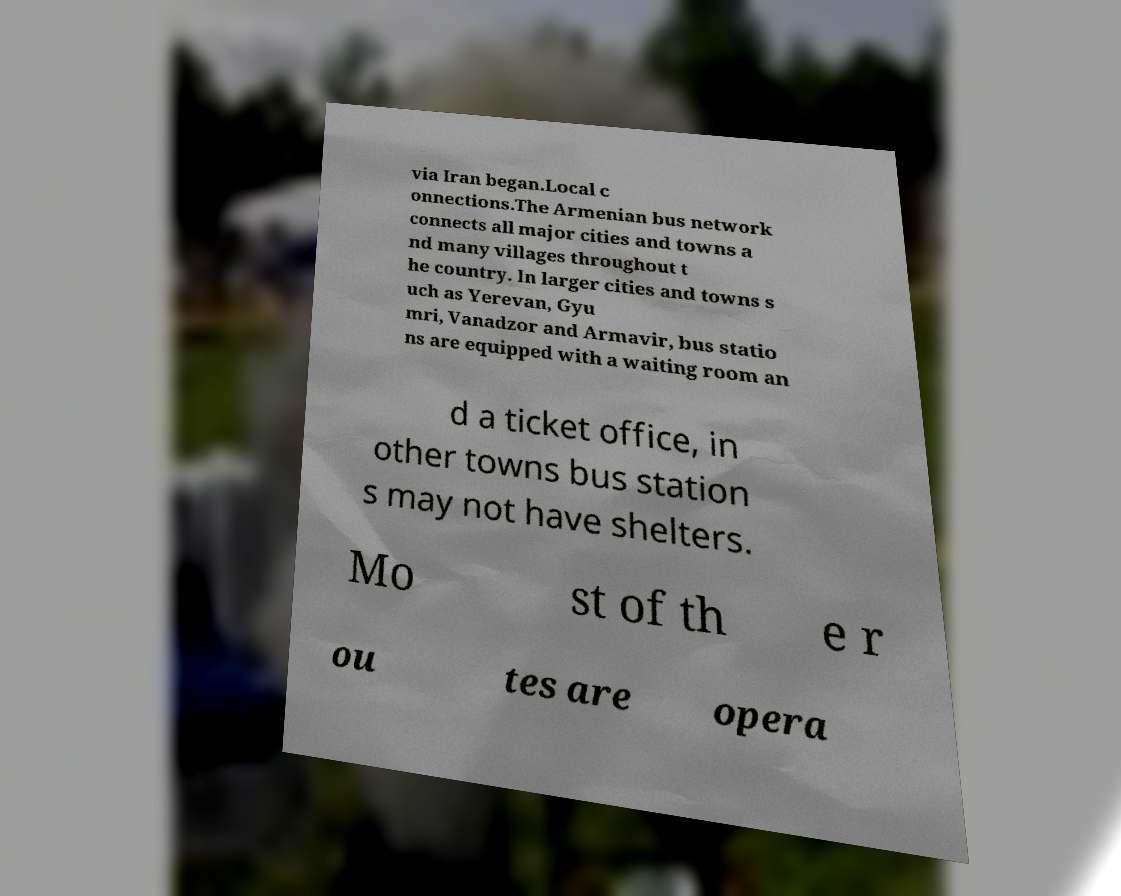Could you extract and type out the text from this image? via Iran began.Local c onnections.The Armenian bus network connects all major cities and towns a nd many villages throughout t he country. In larger cities and towns s uch as Yerevan, Gyu mri, Vanadzor and Armavir, bus statio ns are equipped with a waiting room an d a ticket office, in other towns bus station s may not have shelters. Mo st of th e r ou tes are opera 